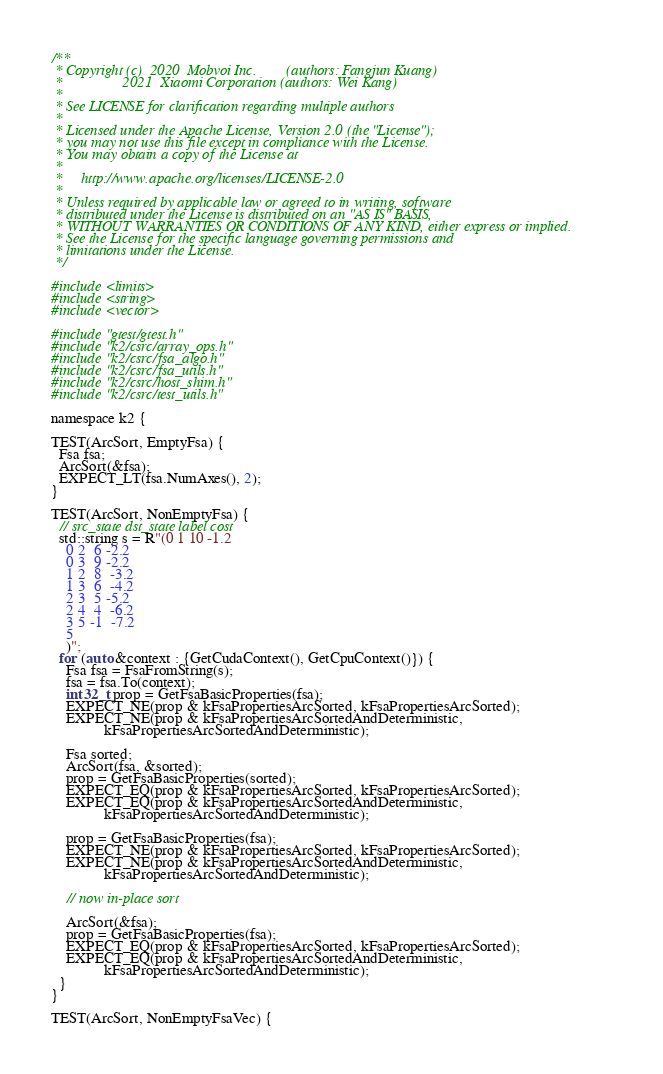Convert code to text. <code><loc_0><loc_0><loc_500><loc_500><_Cuda_>/**
 * Copyright (c)  2020  Mobvoi Inc.        (authors: Fangjun Kuang)
 *                2021  Xiaomi Corporation (authors: Wei Kang)
 *
 * See LICENSE for clarification regarding multiple authors
 *
 * Licensed under the Apache License, Version 2.0 (the "License");
 * you may not use this file except in compliance with the License.
 * You may obtain a copy of the License at
 *
 *     http://www.apache.org/licenses/LICENSE-2.0
 *
 * Unless required by applicable law or agreed to in writing, software
 * distributed under the License is distributed on an "AS IS" BASIS,
 * WITHOUT WARRANTIES OR CONDITIONS OF ANY KIND, either express or implied.
 * See the License for the specific language governing permissions and
 * limitations under the License.
 */

#include <limits>
#include <string>
#include <vector>

#include "gtest/gtest.h"
#include "k2/csrc/array_ops.h"
#include "k2/csrc/fsa_algo.h"
#include "k2/csrc/fsa_utils.h"
#include "k2/csrc/host_shim.h"
#include "k2/csrc/test_utils.h"

namespace k2 {

TEST(ArcSort, EmptyFsa) {
  Fsa fsa;
  ArcSort(&fsa);
  EXPECT_LT(fsa.NumAxes(), 2);
}

TEST(ArcSort, NonEmptyFsa) {
  // src_state dst_state label cost
  std::string s = R"(0 1 10 -1.2
    0 2  6 -2.2
    0 3  9 -2.2
    1 2  8  -3.2
    1 3  6  -4.2
    2 3  5 -5.2
    2 4  4  -6.2
    3 5 -1  -7.2
    5
    )";
  for (auto &context : {GetCudaContext(), GetCpuContext()}) {
    Fsa fsa = FsaFromString(s);
    fsa = fsa.To(context);
    int32_t prop = GetFsaBasicProperties(fsa);
    EXPECT_NE(prop & kFsaPropertiesArcSorted, kFsaPropertiesArcSorted);
    EXPECT_NE(prop & kFsaPropertiesArcSortedAndDeterministic,
              kFsaPropertiesArcSortedAndDeterministic);

    Fsa sorted;
    ArcSort(fsa, &sorted);
    prop = GetFsaBasicProperties(sorted);
    EXPECT_EQ(prop & kFsaPropertiesArcSorted, kFsaPropertiesArcSorted);
    EXPECT_EQ(prop & kFsaPropertiesArcSortedAndDeterministic,
              kFsaPropertiesArcSortedAndDeterministic);

    prop = GetFsaBasicProperties(fsa);
    EXPECT_NE(prop & kFsaPropertiesArcSorted, kFsaPropertiesArcSorted);
    EXPECT_NE(prop & kFsaPropertiesArcSortedAndDeterministic,
              kFsaPropertiesArcSortedAndDeterministic);

    // now in-place sort

    ArcSort(&fsa);
    prop = GetFsaBasicProperties(fsa);
    EXPECT_EQ(prop & kFsaPropertiesArcSorted, kFsaPropertiesArcSorted);
    EXPECT_EQ(prop & kFsaPropertiesArcSortedAndDeterministic,
              kFsaPropertiesArcSortedAndDeterministic);
  }
}

TEST(ArcSort, NonEmptyFsaVec) {</code> 